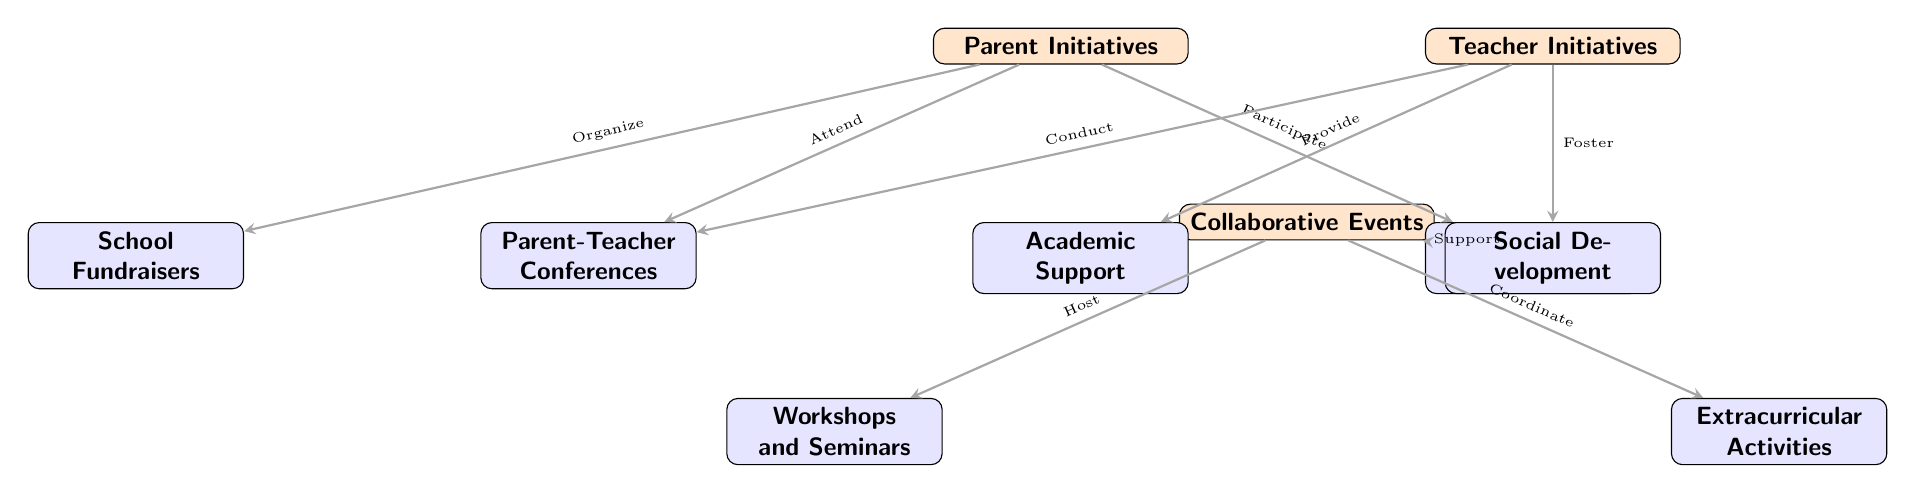What is the first node in the diagram? The first node is labeled "Parent Initiatives," which is the starting point of the diagram's flow.
Answer: Parent Initiatives Which node is connected to "Teacher Initiatives" and "Collaborative Events"? The node that connects both "Teacher Initiatives" and "Collaborative Events" is the "Parent-Teacher Conferences," as it facilitates interaction between parents and teachers.
Answer: Parent-Teacher Conferences How many secondary nodes are there in total? There are six secondary nodes in total, which include Parent-Teacher Conferences, School Fundraisers, Volunteer Programs, Academic Support, Social Development, Workshops and Seminars, and Extracurricular Activities.
Answer: Six What type of activities do parents participate in according to the diagram? According to the diagram, parents participate in "Volunteer Programs," which are specifically listed under the node associated with parent initiatives.
Answer: Volunteer Programs What is the role of teachers in the "Collaborative Events"? Teachers' roles in "Collaborative Events" involve hosting activities such as "Workshops and Seminars" and coordinating "Extracurricular Activities," indicating their active involvement in these events.
Answer: Host and Coordinate Which arrow indicates a relationship where a parent attends an event? The arrow indicating that a parent attends an event is from "Parent Initiatives" to "Parent-Teacher Conferences," signifying parental participation in that particular initiative.
Answer: Attend What two initiatives focus on academic and social development by teachers? The two initiatives that focus on these aspects are "Academic Support" and "Social Development," both linked under "Teacher Initiatives."
Answer: Academic Support and Social Development What connection is there between "Volunteer Programs" and "Collaborative Events"? The connection between "Volunteer Programs" and "Collaborative Events" is a supportive relationship where the volunteer efforts directly help in managing collaborative activities hosted at school.
Answer: Support 